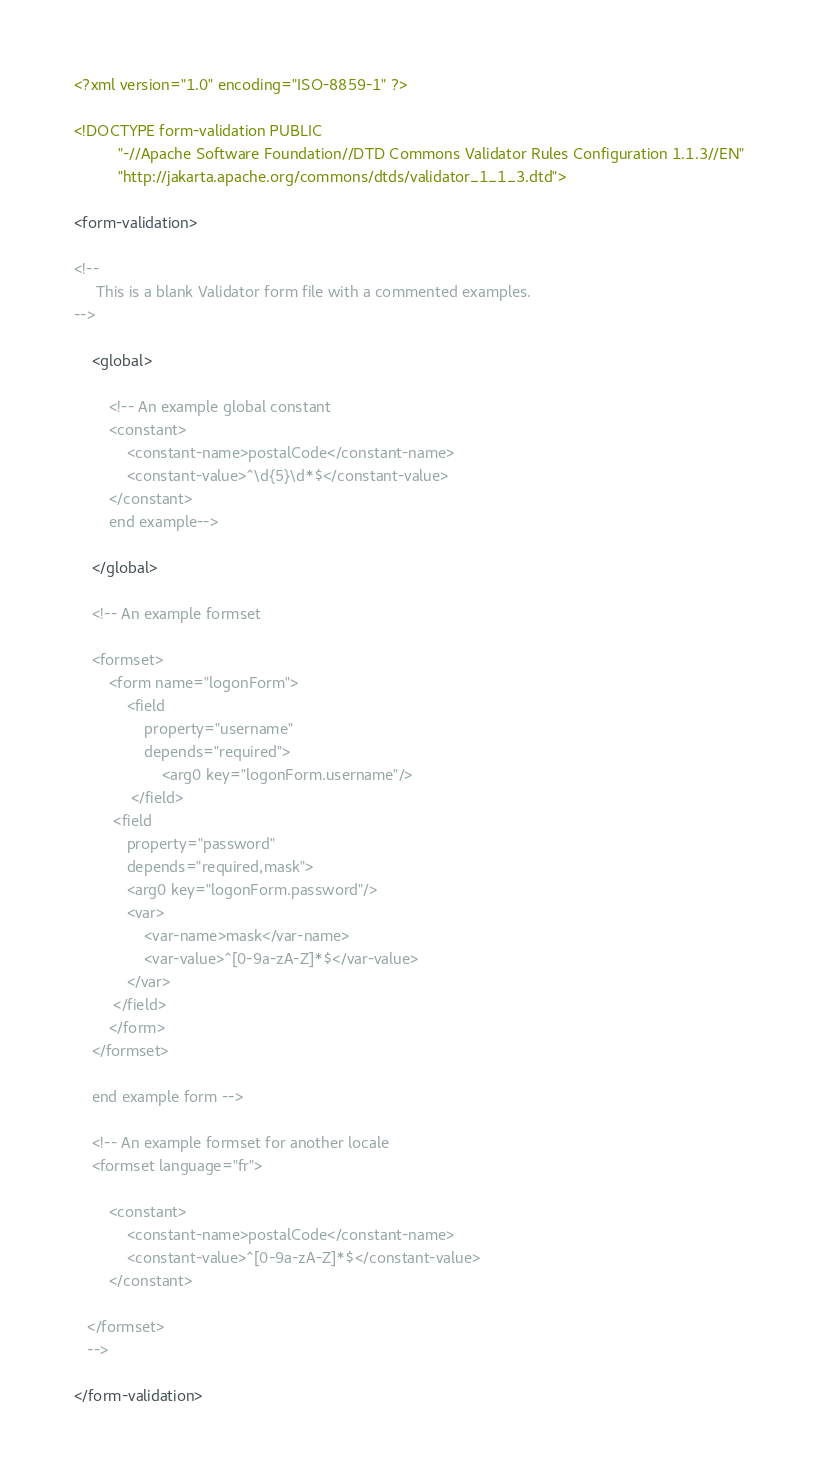Convert code to text. <code><loc_0><loc_0><loc_500><loc_500><_XML_><?xml version="1.0" encoding="ISO-8859-1" ?>

<!DOCTYPE form-validation PUBLIC
          "-//Apache Software Foundation//DTD Commons Validator Rules Configuration 1.1.3//EN"
          "http://jakarta.apache.org/commons/dtds/validator_1_1_3.dtd">

<form-validation>

<!--
     This is a blank Validator form file with a commented examples.
-->

    <global>

        <!-- An example global constant
        <constant>
            <constant-name>postalCode</constant-name>
            <constant-value>^\d{5}\d*$</constant-value>
        </constant>
        end example-->

    </global>

    <!-- An example formset

    <formset>
        <form name="logonForm">
            <field
                property="username"
                depends="required">
                    <arg0 key="logonForm.username"/>
             </field>
         <field
            property="password"
            depends="required,mask">
            <arg0 key="logonForm.password"/>
            <var>
                <var-name>mask</var-name>
                <var-value>^[0-9a-zA-Z]*$</var-value>
            </var>
         </field>
        </form>
    </formset>

    end example form -->

    <!-- An example formset for another locale
    <formset language="fr">

        <constant>
            <constant-name>postalCode</constant-name>
            <constant-value>^[0-9a-zA-Z]*$</constant-value>
        </constant>

   </formset>
   -->

</form-validation>
</code> 